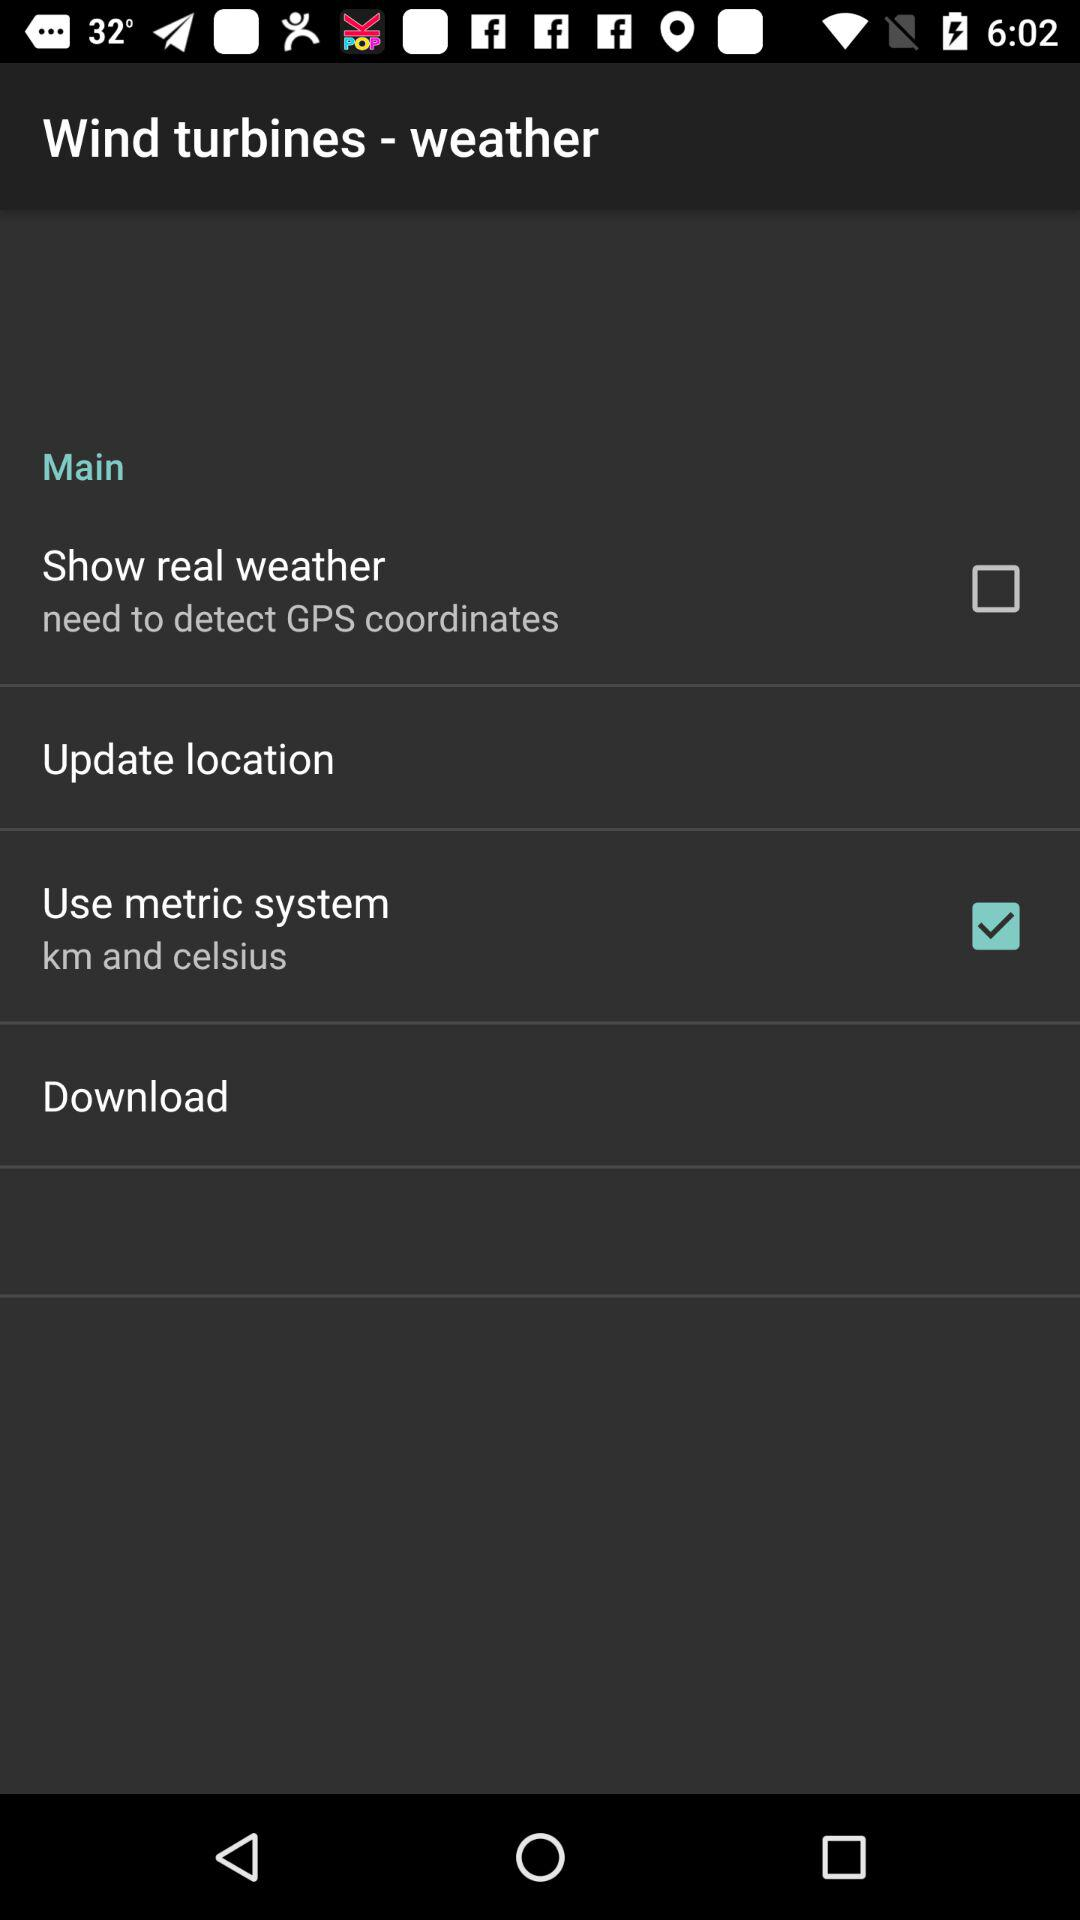What are the units chosen in "Use metric system"? The units chosen in "Use metric system" are kilometres and celsius. 